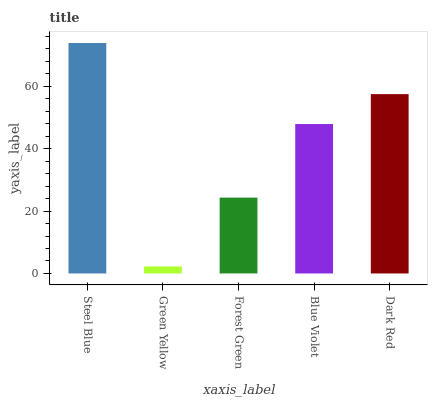Is Forest Green the minimum?
Answer yes or no. No. Is Forest Green the maximum?
Answer yes or no. No. Is Forest Green greater than Green Yellow?
Answer yes or no. Yes. Is Green Yellow less than Forest Green?
Answer yes or no. Yes. Is Green Yellow greater than Forest Green?
Answer yes or no. No. Is Forest Green less than Green Yellow?
Answer yes or no. No. Is Blue Violet the high median?
Answer yes or no. Yes. Is Blue Violet the low median?
Answer yes or no. Yes. Is Dark Red the high median?
Answer yes or no. No. Is Forest Green the low median?
Answer yes or no. No. 